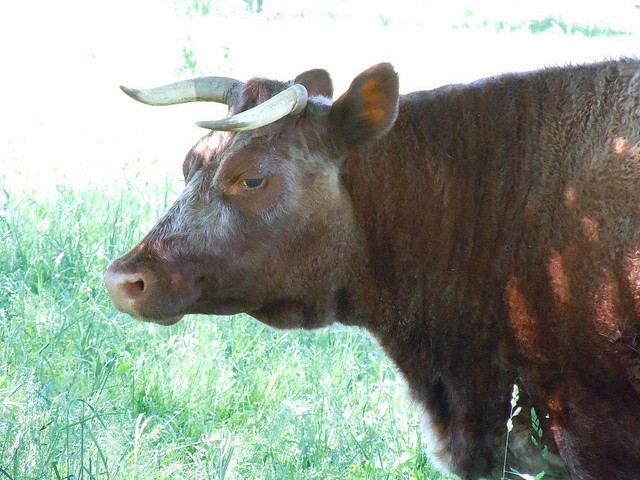Describe the objects in this image and their specific colors. I can see a cow in white, black, gray, and maroon tones in this image. 